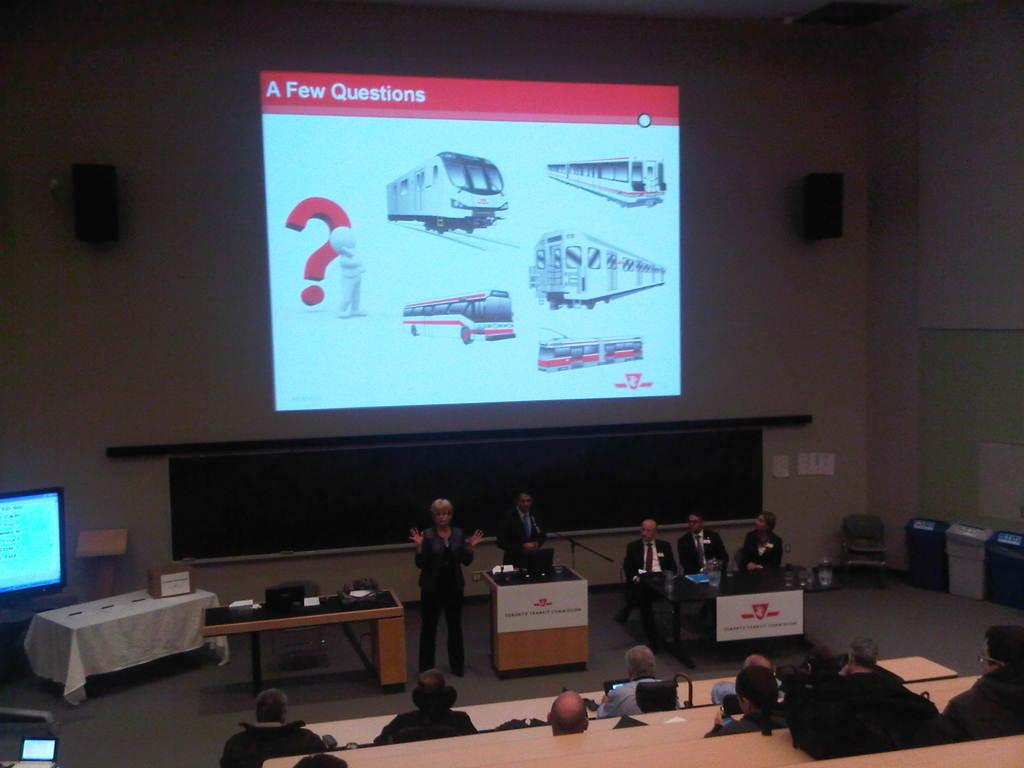<image>
Render a clear and concise summary of the photo. A press conference with a screen on the wall that says "A Few Questions". 